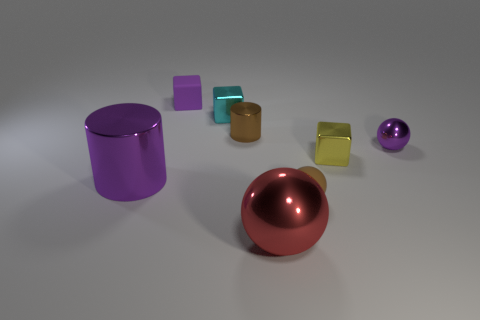Is there any other thing that has the same size as the cyan shiny object?
Offer a terse response. Yes. What material is the brown object that is behind the block that is right of the large sphere?
Your answer should be very brief. Metal. What is the shape of the object that is to the left of the cyan metallic thing and behind the tiny brown cylinder?
Your answer should be compact. Cube. What size is the cyan shiny object that is the same shape as the tiny purple rubber thing?
Ensure brevity in your answer.  Small. Is the number of large purple objects that are on the right side of the rubber cube less than the number of small brown objects?
Your answer should be very brief. Yes. What size is the rubber thing that is on the left side of the small brown cylinder?
Make the answer very short. Small. There is a matte thing that is the same shape as the large red shiny thing; what color is it?
Offer a very short reply. Brown. What number of other big spheres are the same color as the big sphere?
Your answer should be very brief. 0. Is there any other thing that has the same shape as the cyan thing?
Your response must be concise. Yes. Is there a tiny yellow cube that is to the left of the tiny rubber thing behind the tiny purple object in front of the purple block?
Ensure brevity in your answer.  No. 